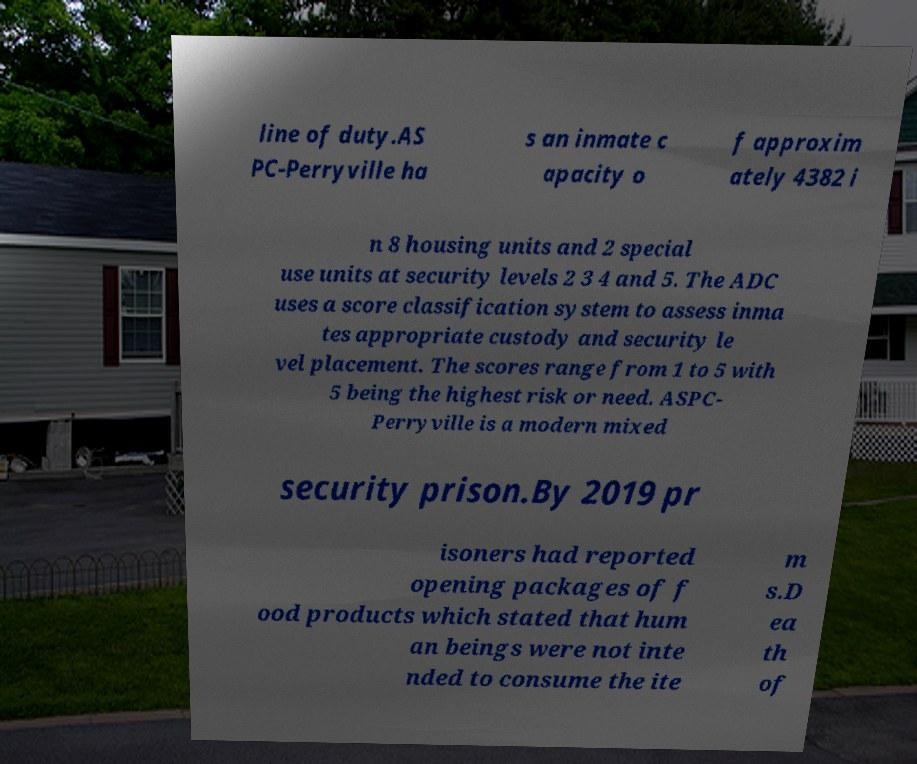There's text embedded in this image that I need extracted. Can you transcribe it verbatim? line of duty.AS PC-Perryville ha s an inmate c apacity o f approxim ately 4382 i n 8 housing units and 2 special use units at security levels 2 3 4 and 5. The ADC uses a score classification system to assess inma tes appropriate custody and security le vel placement. The scores range from 1 to 5 with 5 being the highest risk or need. ASPC- Perryville is a modern mixed security prison.By 2019 pr isoners had reported opening packages of f ood products which stated that hum an beings were not inte nded to consume the ite m s.D ea th of 